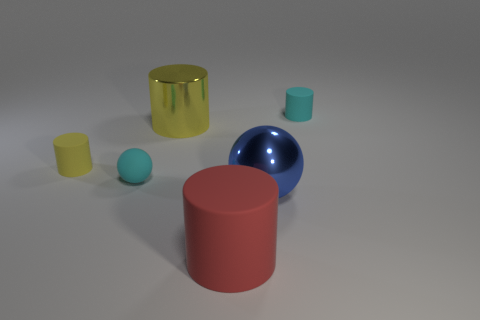Do the tiny object to the right of the big matte cylinder and the tiny sphere have the same color?
Keep it short and to the point. Yes. There is a cyan matte sphere in front of the metal thing behind the yellow rubber cylinder; how big is it?
Provide a short and direct response. Small. What material is the other cylinder that is the same size as the metal cylinder?
Keep it short and to the point. Rubber. How many other things are there of the same size as the blue metal thing?
Offer a terse response. 2. What number of cylinders are shiny things or small yellow matte objects?
Your answer should be very brief. 2. What material is the small cylinder behind the large metal object behind the cylinder that is left of the cyan sphere made of?
Make the answer very short. Rubber. What number of big spheres are the same material as the small ball?
Provide a succinct answer. 0. Do the cyan rubber object that is in front of the shiny cylinder and the big red object have the same size?
Offer a very short reply. No. There is a big cylinder that is the same material as the cyan sphere; what is its color?
Provide a short and direct response. Red. There is a blue metal object; what number of cylinders are in front of it?
Give a very brief answer. 1. 